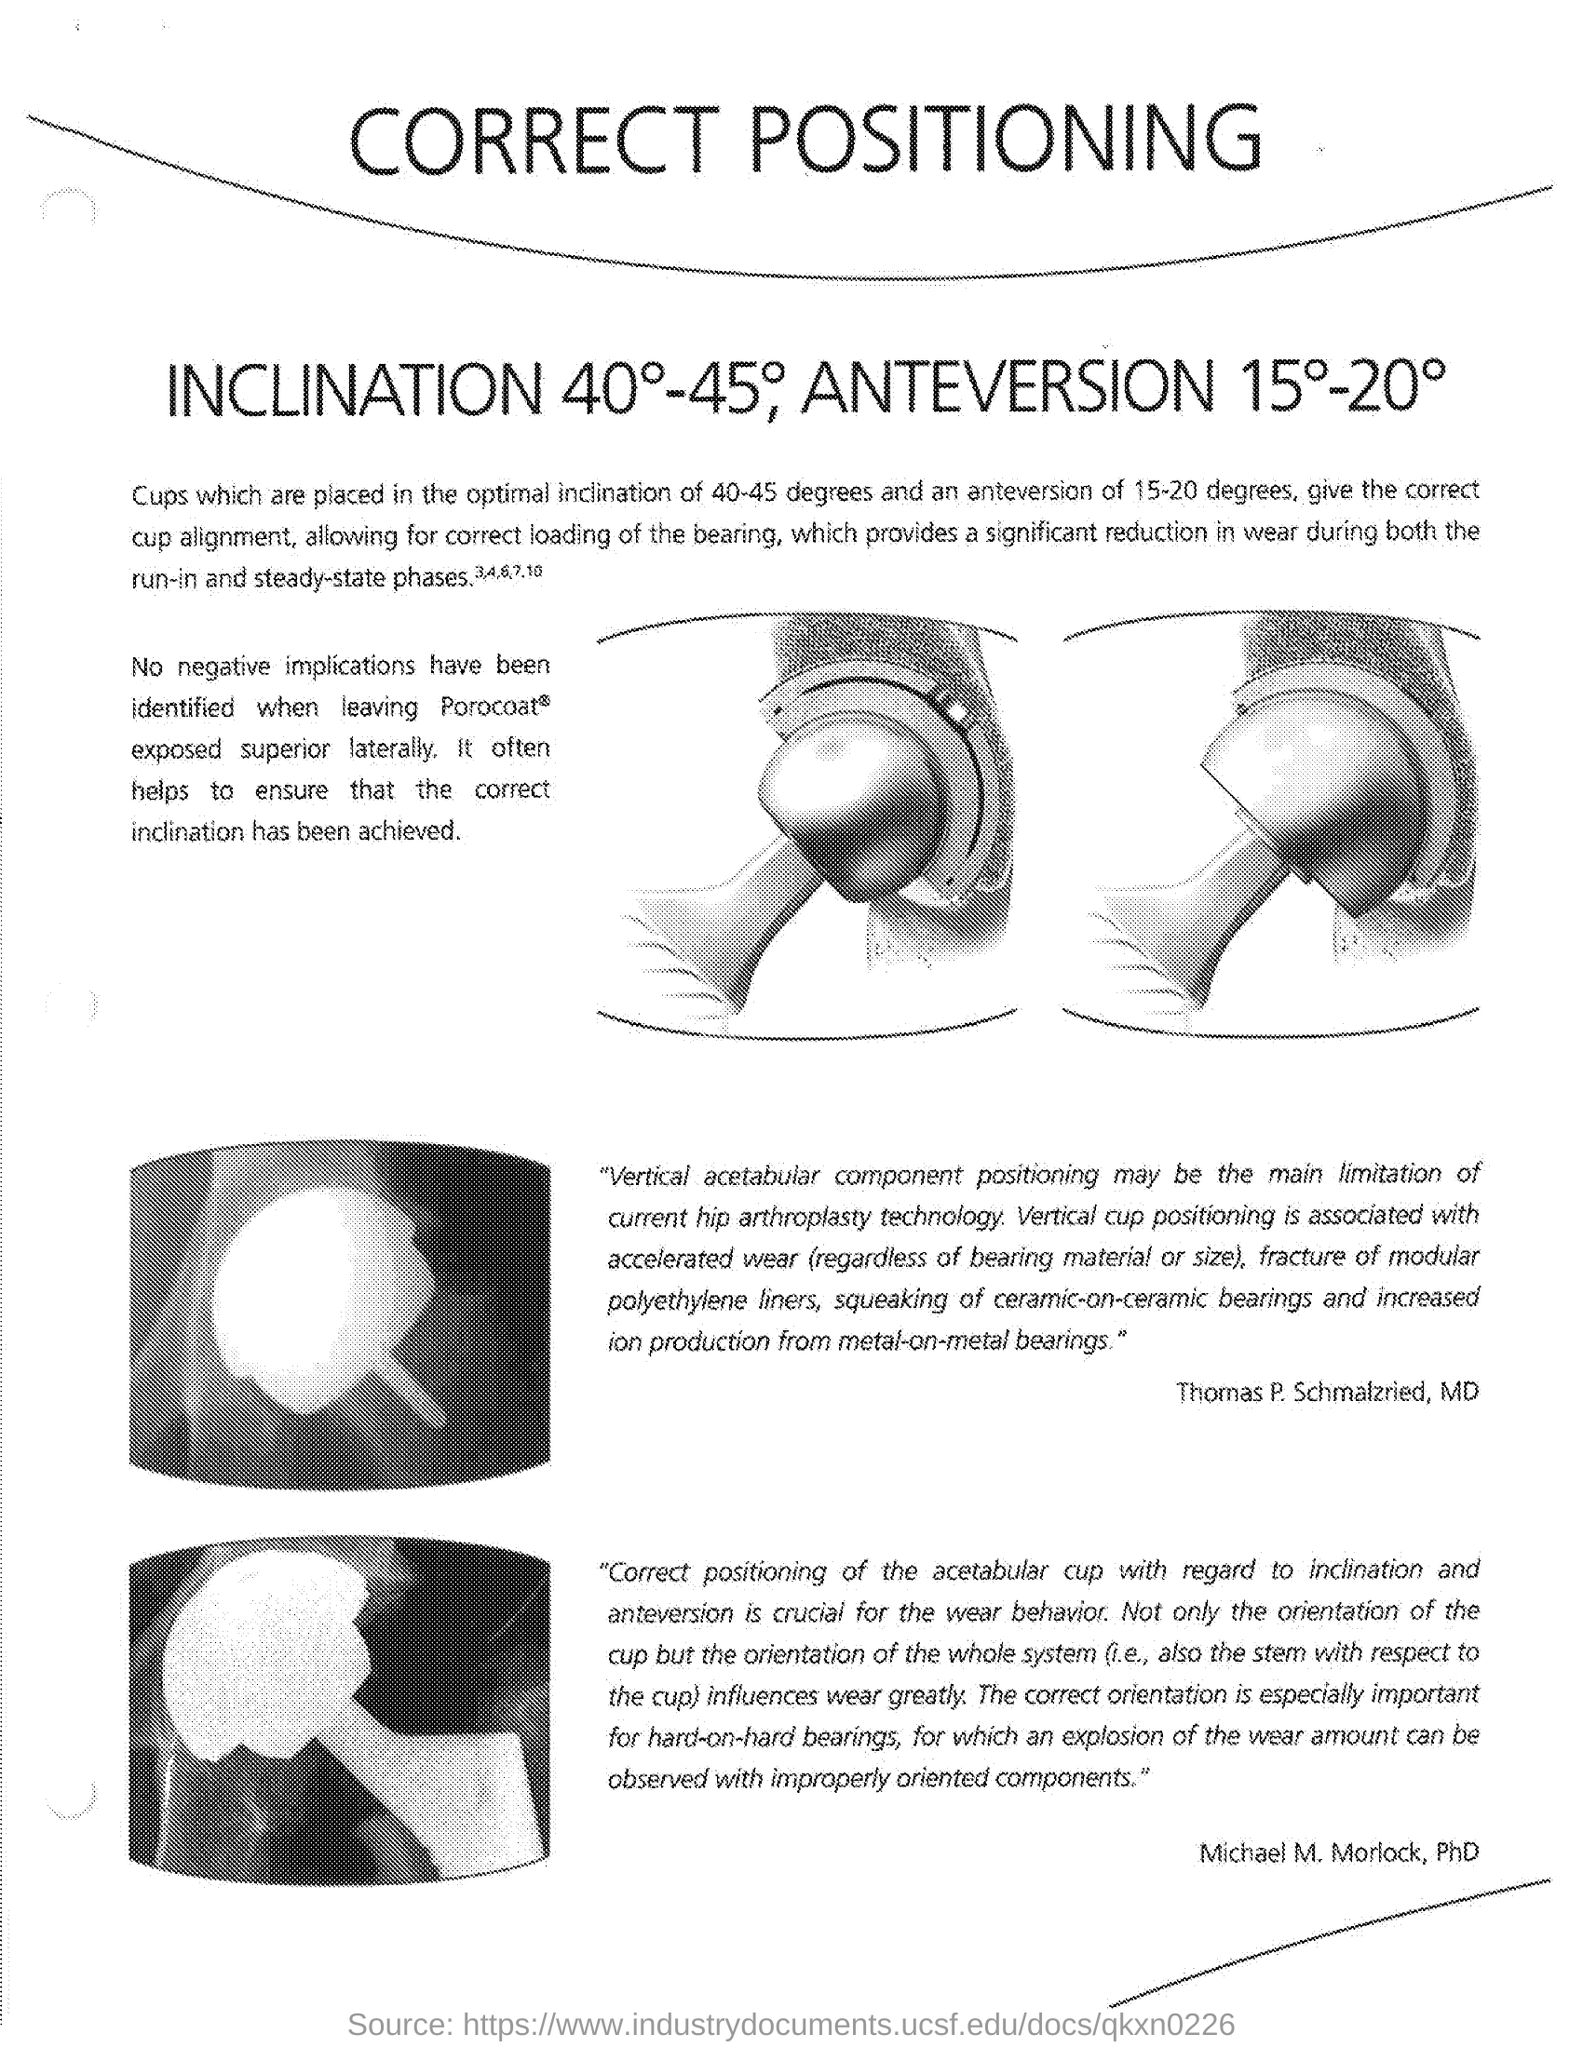What is the title of the document?
Give a very brief answer. Correct Positioning. 